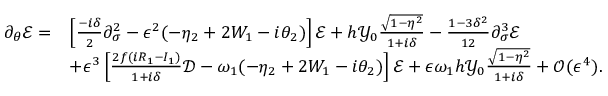Convert formula to latex. <formula><loc_0><loc_0><loc_500><loc_500>\begin{array} { r l } { \partial _ { \theta } \mathcal { E } = } & { \left [ \frac { - i \delta } { 2 } \partial _ { \sigma } ^ { 2 } - \epsilon ^ { 2 } ( - \eta _ { 2 } + 2 W _ { 1 } - i \theta _ { 2 } ) \right ] \mathcal { E } + h \mathcal { Y } _ { 0 } \frac { \sqrt { 1 - \eta ^ { 2 } } } { 1 + i \delta } - \frac { 1 - 3 \delta ^ { 2 } } { 1 2 } \partial _ { \sigma } ^ { 3 } \mathcal { E } } \\ & { + \epsilon ^ { 3 } \left [ \frac { 2 f ( i R _ { 1 } - I _ { 1 } ) } { 1 + i \delta } \mathcal { D } - \omega _ { 1 } ( - \eta _ { 2 } + 2 W _ { 1 } - i \theta _ { 2 } ) \right ] \mathcal { E } + \epsilon \omega _ { 1 } h \mathcal { Y } _ { 0 } \frac { \sqrt { 1 - \eta ^ { 2 } } } { 1 + i \delta } + \mathcal { O } ( \epsilon ^ { 4 } ) . } \end{array}</formula> 